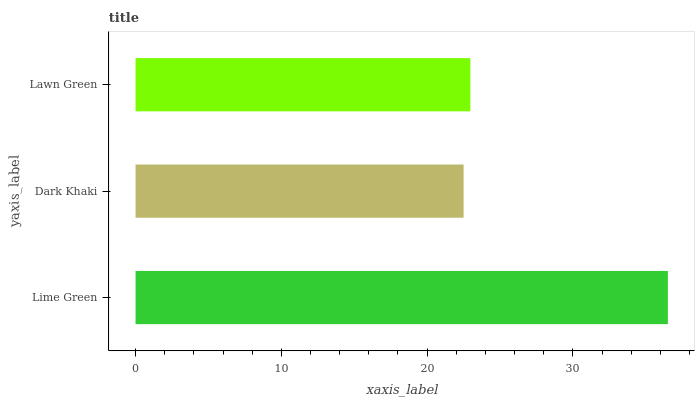Is Dark Khaki the minimum?
Answer yes or no. Yes. Is Lime Green the maximum?
Answer yes or no. Yes. Is Lawn Green the minimum?
Answer yes or no. No. Is Lawn Green the maximum?
Answer yes or no. No. Is Lawn Green greater than Dark Khaki?
Answer yes or no. Yes. Is Dark Khaki less than Lawn Green?
Answer yes or no. Yes. Is Dark Khaki greater than Lawn Green?
Answer yes or no. No. Is Lawn Green less than Dark Khaki?
Answer yes or no. No. Is Lawn Green the high median?
Answer yes or no. Yes. Is Lawn Green the low median?
Answer yes or no. Yes. Is Lime Green the high median?
Answer yes or no. No. Is Lime Green the low median?
Answer yes or no. No. 